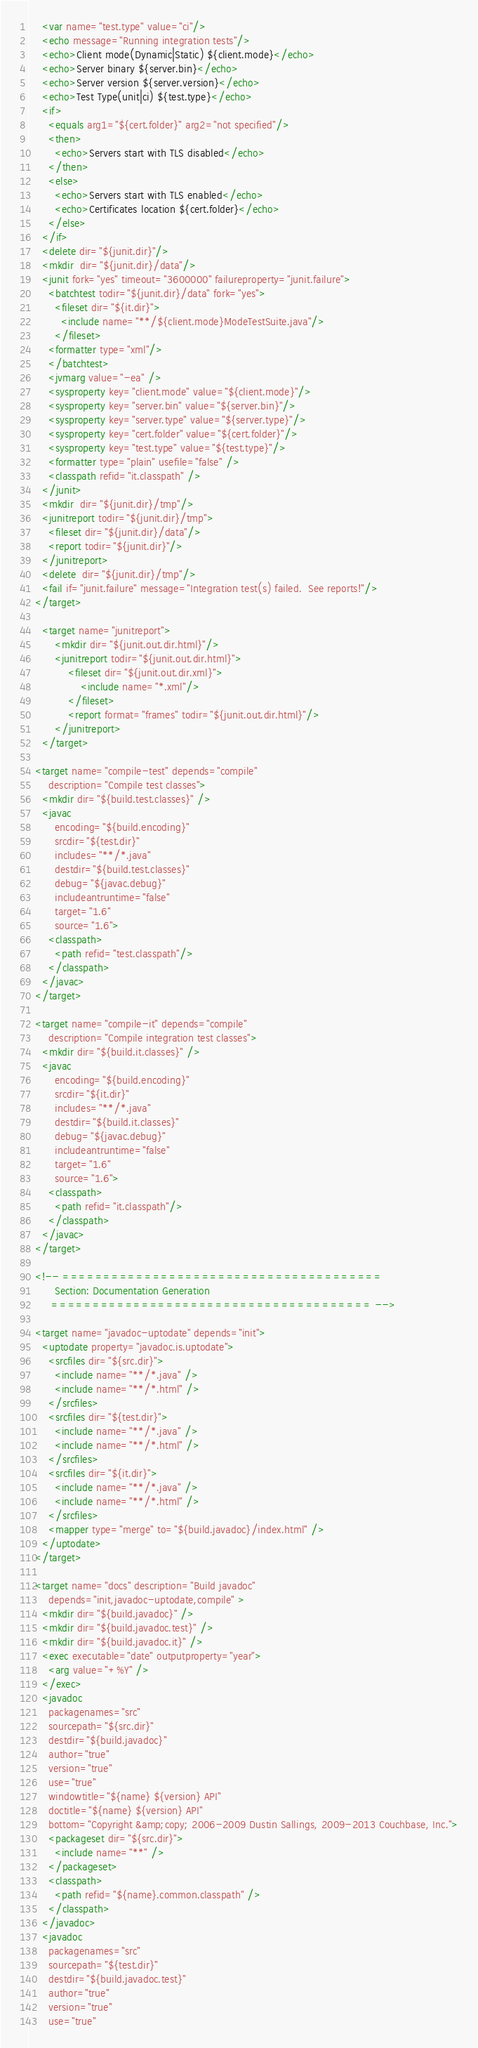<code> <loc_0><loc_0><loc_500><loc_500><_XML_>    <var name="test.type" value="ci"/>
    <echo message="Running integration tests"/>
    <echo>Client mode(Dynamic|Static) ${client.mode}</echo>
    <echo>Server binary ${server.bin}</echo>
    <echo>Server version ${server.version}</echo>
    <echo>Test Type(unit|ci) ${test.type}</echo>
    <if>
      <equals arg1="${cert.folder}" arg2="not specified"/>
      <then>
        <echo>Servers start with TLS disabled</echo>
      </then>
      <else>
        <echo>Servers start with TLS enabled</echo>
        <echo>Certificates location ${cert.folder}</echo>
      </else>
    </if>
    <delete dir="${junit.dir}"/>
    <mkdir  dir="${junit.dir}/data"/>
    <junit fork="yes" timeout="3600000" failureproperty="junit.failure">
      <batchtest todir="${junit.dir}/data" fork="yes">
        <fileset dir="${it.dir}">
          <include name="**/${client.mode}ModeTestSuite.java"/>
        </fileset>
      <formatter type="xml"/>
      </batchtest>
      <jvmarg value="-ea" />
      <sysproperty key="client.mode" value="${client.mode}"/>
      <sysproperty key="server.bin" value="${server.bin}"/>
      <sysproperty key="server.type" value="${server.type}"/>
      <sysproperty key="cert.folder" value="${cert.folder}"/>
      <sysproperty key="test.type" value="${test.type}"/>
      <formatter type="plain" usefile="false" />
      <classpath refid="it.classpath" />
    </junit>
    <mkdir  dir="${junit.dir}/tmp"/>
    <junitreport todir="${junit.dir}/tmp">
      <fileset dir="${junit.dir}/data"/>
      <report todir="${junit.dir}"/>
    </junitreport>
    <delete  dir="${junit.dir}/tmp"/>
    <fail if="junit.failure" message="Integration test(s) failed.  See reports!"/>
  </target>

    <target name="junitreport">
        <mkdir dir="${junit.out.dir.html}"/>
        <junitreport todir="${junit.out.dir.html}">
            <fileset dir="${junit.out.dir.xml}">
                <include name="*.xml"/>
            </fileset>
            <report format="frames" todir="${junit.out.dir.html}"/>
        </junitreport>
    </target>

  <target name="compile-test" depends="compile"
      description="Compile test classes">
    <mkdir dir="${build.test.classes}" />
    <javac
        encoding="${build.encoding}"
        srcdir="${test.dir}"
        includes="**/*.java"
        destdir="${build.test.classes}"
        debug="${javac.debug}"
        includeantruntime="false"
        target="1.6"
        source="1.6">
      <classpath>
        <path refid="test.classpath"/>
      </classpath>
    </javac>
  </target>

  <target name="compile-it" depends="compile"
      description="Compile integration test classes">
    <mkdir dir="${build.it.classes}" />
    <javac
        encoding="${build.encoding}"
        srcdir="${it.dir}"
        includes="**/*.java"
        destdir="${build.it.classes}"
        debug="${javac.debug}"
        includeantruntime="false"
        target="1.6"
        source="1.6">
      <classpath>
        <path refid="it.classpath"/>
      </classpath>
    </javac>
  </target>

  <!-- =======================================
        Section: Documentation Generation
       ======================================= -->

  <target name="javadoc-uptodate" depends="init">
    <uptodate property="javadoc.is.uptodate">
      <srcfiles dir="${src.dir}">
        <include name="**/*.java" />
        <include name="**/*.html" />
      </srcfiles>
      <srcfiles dir="${test.dir}">
        <include name="**/*.java" />
        <include name="**/*.html" />
      </srcfiles>
      <srcfiles dir="${it.dir}">
        <include name="**/*.java" />
        <include name="**/*.html" />
      </srcfiles>
      <mapper type="merge" to="${build.javadoc}/index.html" />
    </uptodate>
  </target>

  <target name="docs" description="Build javadoc"
      depends="init,javadoc-uptodate,compile" >
    <mkdir dir="${build.javadoc}" />
    <mkdir dir="${build.javadoc.test}" />
    <mkdir dir="${build.javadoc.it}" />
    <exec executable="date" outputproperty="year">
      <arg value="+%Y" />
    </exec>
    <javadoc
      packagenames="src"
      sourcepath="${src.dir}"
      destdir="${build.javadoc}"
      author="true"
      version="true"
      use="true"
      windowtitle="${name} ${version} API"
      doctitle="${name} ${version} API"
      bottom="Copyright &amp;copy; 2006-2009 Dustin Sallings, 2009-2013 Couchbase, Inc.">
      <packageset dir="${src.dir}">
        <include name="**" />
      </packageset>
      <classpath>
        <path refid="${name}.common.classpath" />
      </classpath>
    </javadoc>
    <javadoc
      packagenames="src"
      sourcepath="${test.dir}"
      destdir="${build.javadoc.test}"
      author="true"
      version="true"
      use="true"</code> 